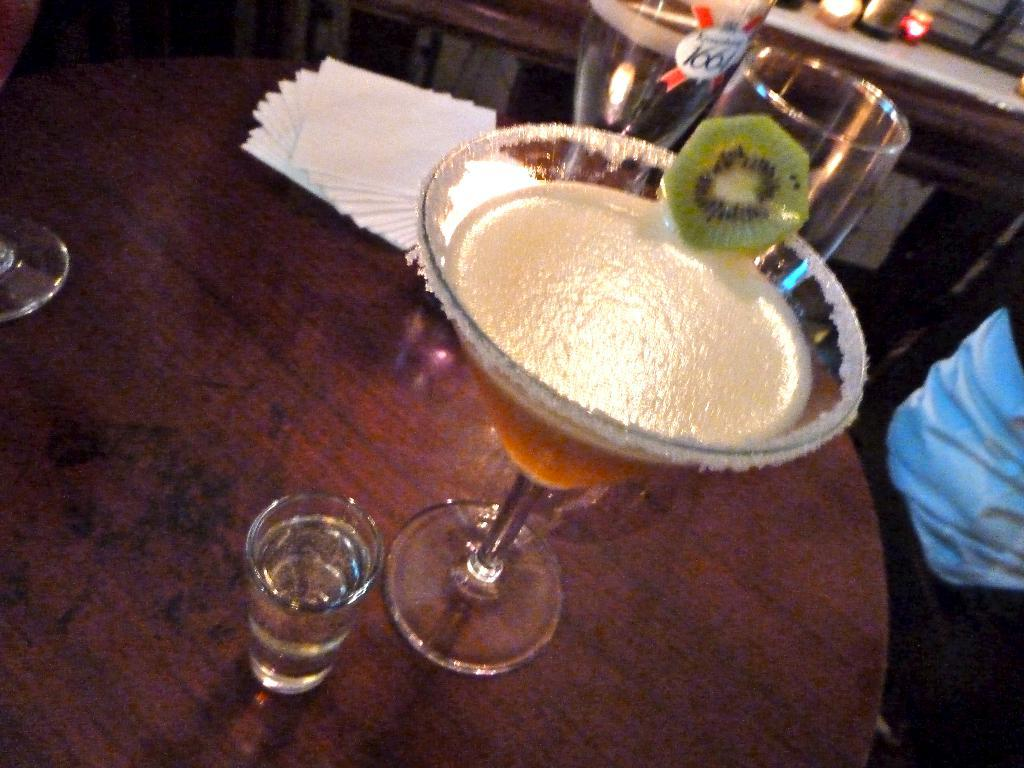What objects are on the wooden surface in the image? There are glasses and tissue papers on the wooden surface. What is on the wooden surface besides the glasses and tissue papers? There is juice on the wooden surface. Can you describe the person on the right side of the image? The provided facts do not give any details about the person's appearance or actions. What is visible at the top of the image? It appears that there is a wall at the top of the image. How many cars are parked in front of the wall in the image? There are no cars visible in the image; it only shows glasses, tissue papers, juice, and a person on the wooden surface. 